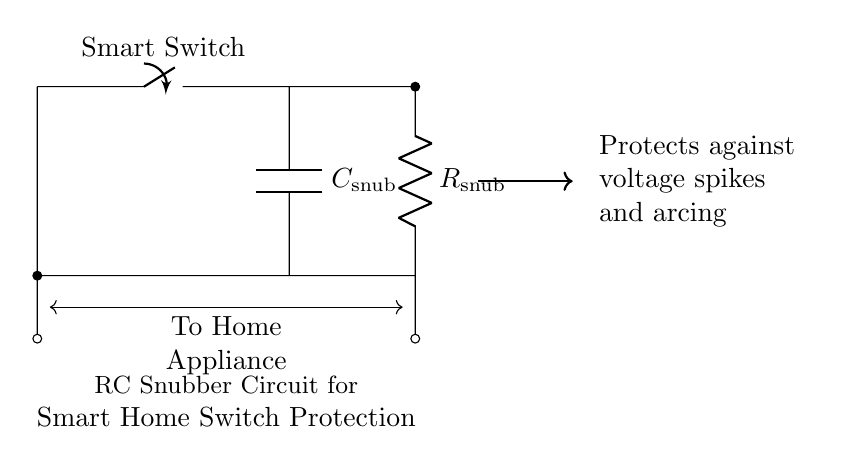What does the symbol labeled as "Smart Switch" represent? The "Smart Switch" symbolizes a physical switch that can control the power supply to a home appliance. It's the component that allows the user to turn the appliance on or off.
Answer: Smart Switch What are the two main components in this circuit? The two main components shown in this circuit are a resistor and a capacitor. They are often used together in RC snubber circuits to suppress voltage transients.
Answer: Resistor and Capacitor What is the purpose of the RC snubber circuit? The RC snubber circuit is designed to protect smart home switches from voltage spikes and arcing that can occur when the switch opens or closes. This protects the longevity of the switch and connected appliances.
Answer: Protects against voltage spikes and arcing Where are the terminals connected in the circuit? The terminals are connected from the smart switch to a home appliance, with the RC components placed parallel to the switch. The snubber components are positioned to help manage surges in current.
Answer: Parallel to Smart Switch How does the arrangement of the resistor and capacitor affect circuit performance? The arrangement of the resistor and capacitor determines the time constant of the circuit, which dictates how quickly the circuit can respond to voltage changes. This influences the effectiveness of spike suppression.
Answer: Affects time constant and spike suppression What is the label of the resistor in this circuit? The resistor in this circuit is labeled as "R snub," indicating its purpose as part of the snubber circuit to manage voltage transients.
Answer: R snub What does the arrow indicating "To Home Appliance" suggest? The arrow labeled "To Home Appliance" suggests the direction of current flow toward the appliance. This shows that the circuit is designed to connect the smart switch to an external load or device.
Answer: Direction of current flow 